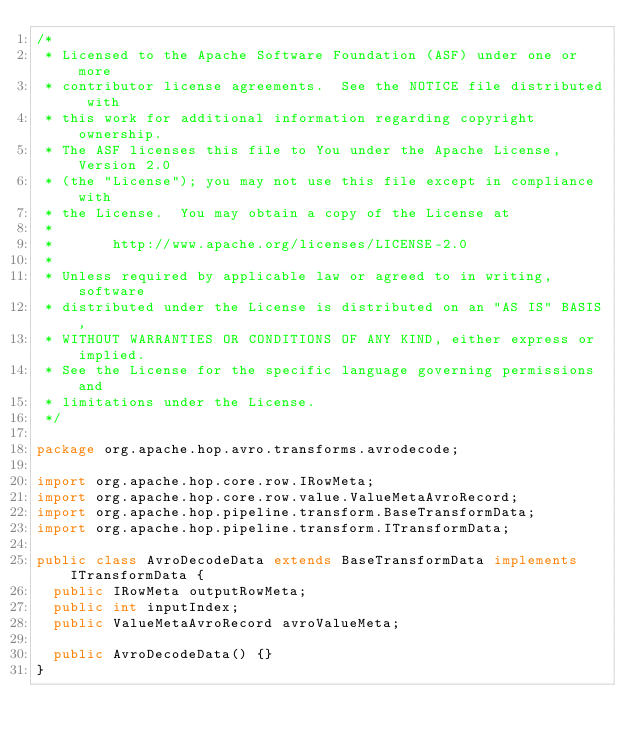Convert code to text. <code><loc_0><loc_0><loc_500><loc_500><_Java_>/*
 * Licensed to the Apache Software Foundation (ASF) under one or more
 * contributor license agreements.  See the NOTICE file distributed with
 * this work for additional information regarding copyright ownership.
 * The ASF licenses this file to You under the Apache License, Version 2.0
 * (the "License"); you may not use this file except in compliance with
 * the License.  You may obtain a copy of the License at
 *
 *       http://www.apache.org/licenses/LICENSE-2.0
 *
 * Unless required by applicable law or agreed to in writing, software
 * distributed under the License is distributed on an "AS IS" BASIS,
 * WITHOUT WARRANTIES OR CONDITIONS OF ANY KIND, either express or implied.
 * See the License for the specific language governing permissions and
 * limitations under the License.
 */

package org.apache.hop.avro.transforms.avrodecode;

import org.apache.hop.core.row.IRowMeta;
import org.apache.hop.core.row.value.ValueMetaAvroRecord;
import org.apache.hop.pipeline.transform.BaseTransformData;
import org.apache.hop.pipeline.transform.ITransformData;

public class AvroDecodeData extends BaseTransformData implements ITransformData {
  public IRowMeta outputRowMeta;
  public int inputIndex;
  public ValueMetaAvroRecord avroValueMeta;

  public AvroDecodeData() {}
}
</code> 